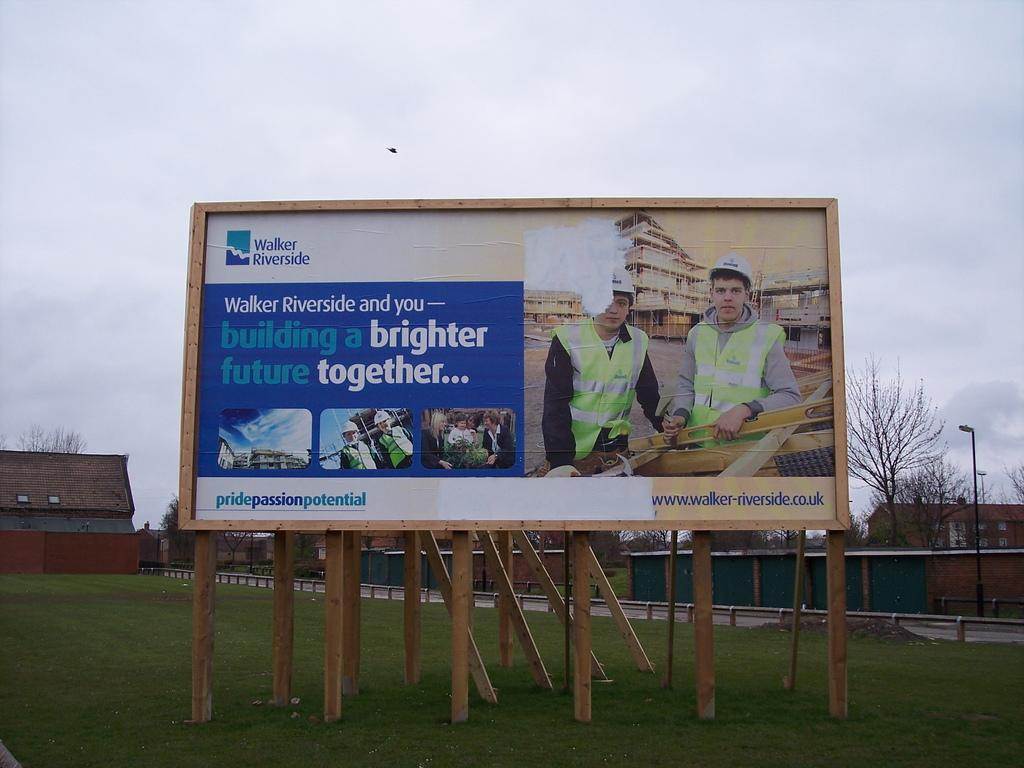<image>
Render a clear and concise summary of the photo. A billboard for the company Walker Riverside with the slogan Pride, Passion, Potential at the bottom. 